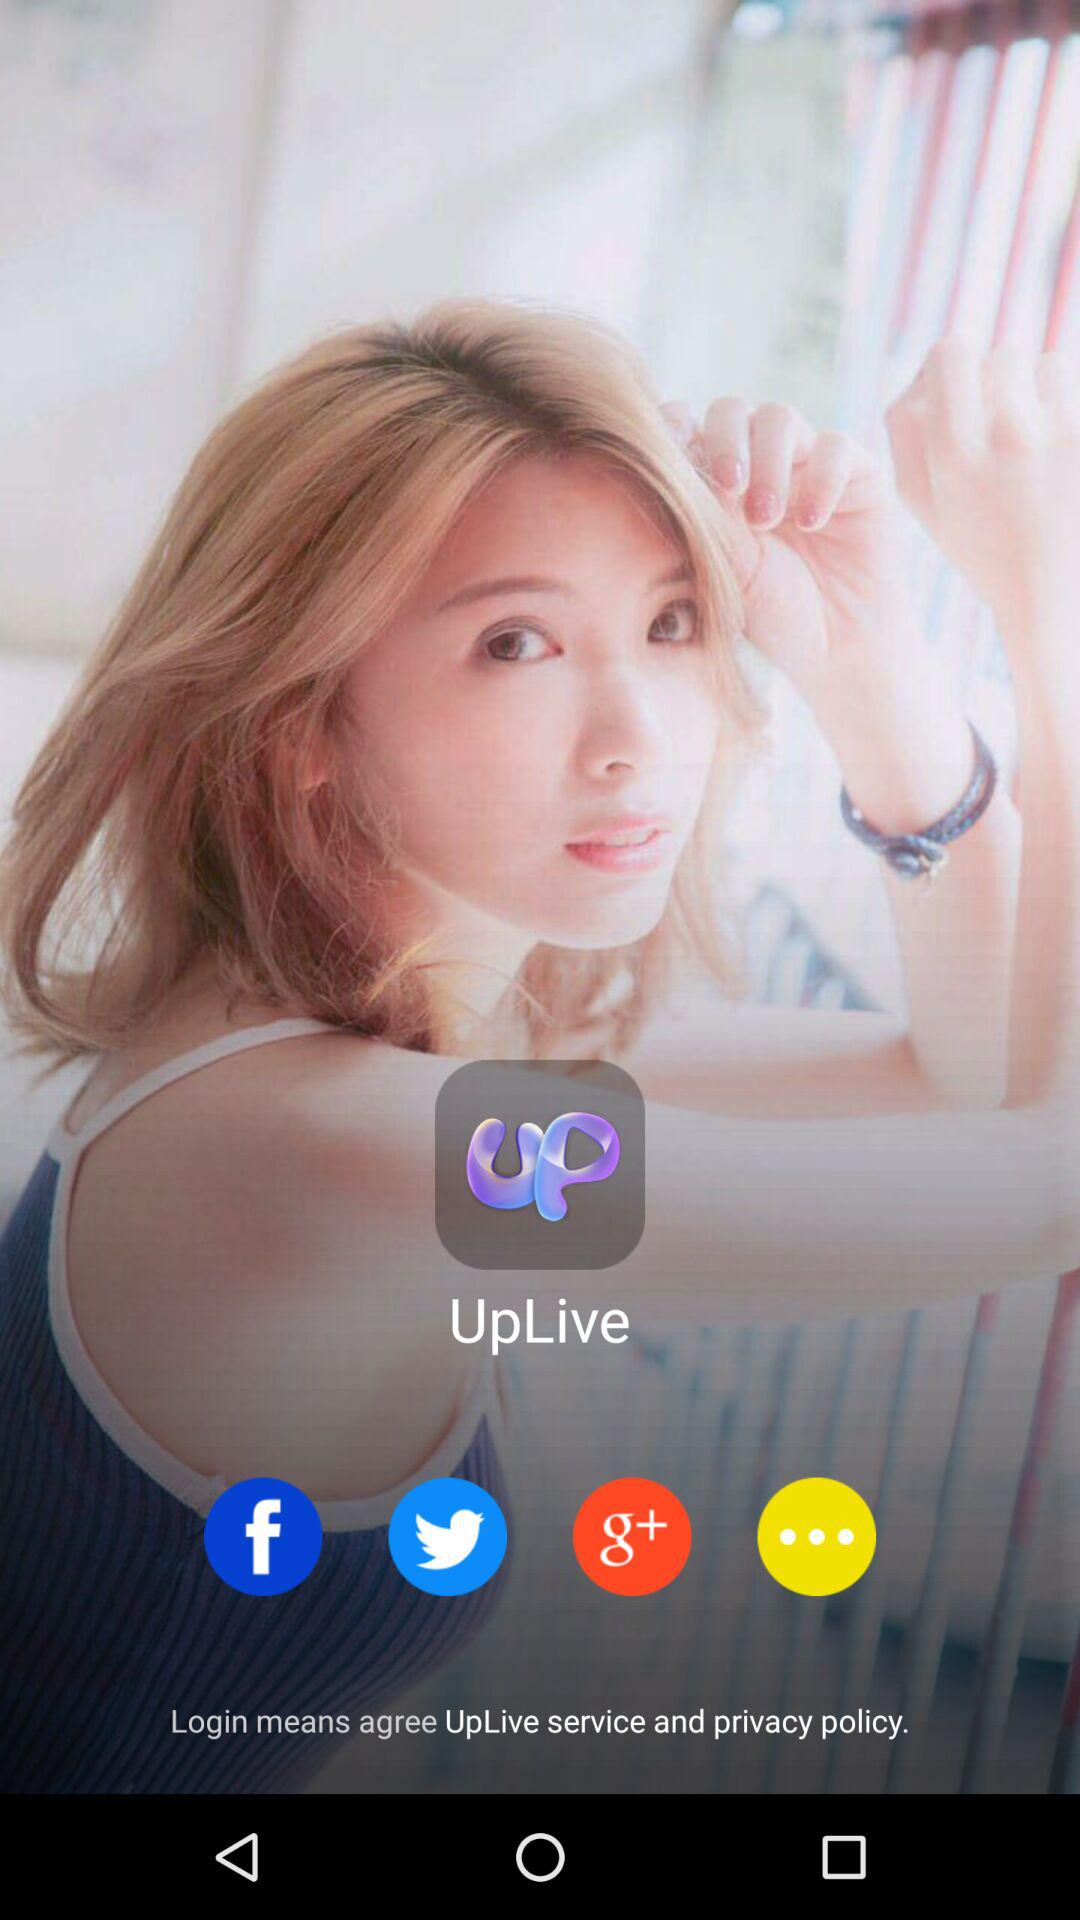What are the different available log in options? The different available log in options are "Facebook", "Twitter" and "Google+". 